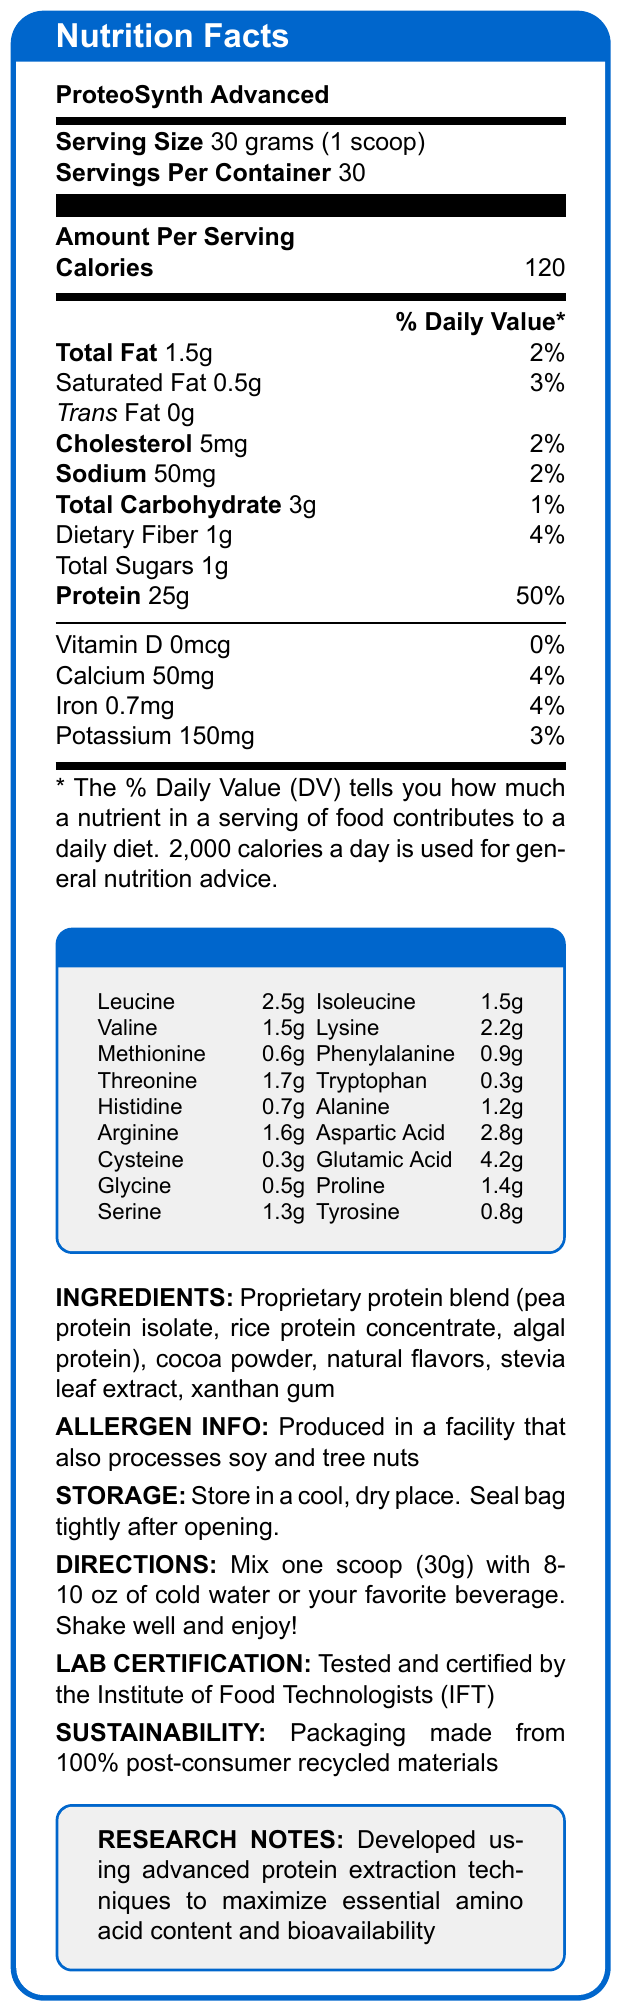what is the serving size for ProteoSynth Advanced? The serving size is explicitly mentioned as 30 grams or 1 scoop in the Nutrition Facts section of the document.
Answer: 30 grams (1 scoop) how many calories are in one serving? The amount of calories per serving is clearly stated as 120 in the Amount Per Serving section.
Answer: 120 how much protein is in each serving? The document specifies that each serving contains 25 grams of protein.
Answer: 25 grams what is the daily value percentage for calcium per serving? The daily value for calcium per serving is listed as 4%.
Answer: 4% which amino acid is present in the highest amount? Glutamic Acid is present at 4.2 grams, which is the highest amount among the amino acids listed.
Answer: Glutamic Acid What is the amount of dietary fiber per serving? The document mentions that each serving contains 1 gram of dietary fiber.
Answer: 1 gram Which ingredient is not part of the proprietary protein blend? A. Pea protein isolate B. Rice protein concentrate C. Cocoa powder D. Algal protein The proprietary protein blend includes pea protein isolate, rice protein concentrate, and algal protein, but not cocoa powder.
Answer: C. Cocoa powder What is the daily value percentage for total fat per serving? A. 2% B. 5% C. 10% D. 15% The daily value percentage for total fat is indicated as 2%.
Answer: A. 2% Is the product gluten-free? The document does not provide any information regarding the presence or absence of gluten.
Answer: Cannot be determined What is the main purpose of the product? The primary purpose of ProteoSynth Advanced is to serve as a high-protein supplement, as indicated by the focus on protein content and amino acid profile.
Answer: Provide a high-protein supplement What certification does the product have? The document states that the product has been tested and certified by IFT.
Answer: Tested and certified by the Institute of Food Technologists (IFT) What are the storage instructions for the product? The document provides specific storage instructions to keep the product in a cool, dry place and to seal the bag tightly after opening.
Answer: Store in a cool, dry place. Seal bag tightly after opening. How many servings are in one container? The document specifies that there are 30 servings per container.
Answer: 30 servings Summarize the main content of the document. The explanation elaborates on the primary focus on the protein content and amino acid profile, along with essential product details like ingredients, certification, and sustainability efforts.
Answer: The document provides detailed Nutrition Facts for ProteoSynth Advanced, a high-protein supplement. Key information includes serving size (30 grams), calories (120), and protein content (25 grams per serving). It lists amino acids, ingredients, allergen info, storage instructions, directions for use, lab certification by IFT, and sustainability information regarding the packaging. What is the daily value percentage for saturated fat in each serving? The daily value for saturated fat is listed as 3% per serving.
Answer: 3% How is the product sweetened? The document mentions that the product uses stevia leaf extract as a sweetener.
Answer: Stevia leaf extract True or False: The product contains soy. The document states that the product is produced in a facility that processes soy, but it does not explicitly list soy as an ingredient in the product itself.
Answer: False 